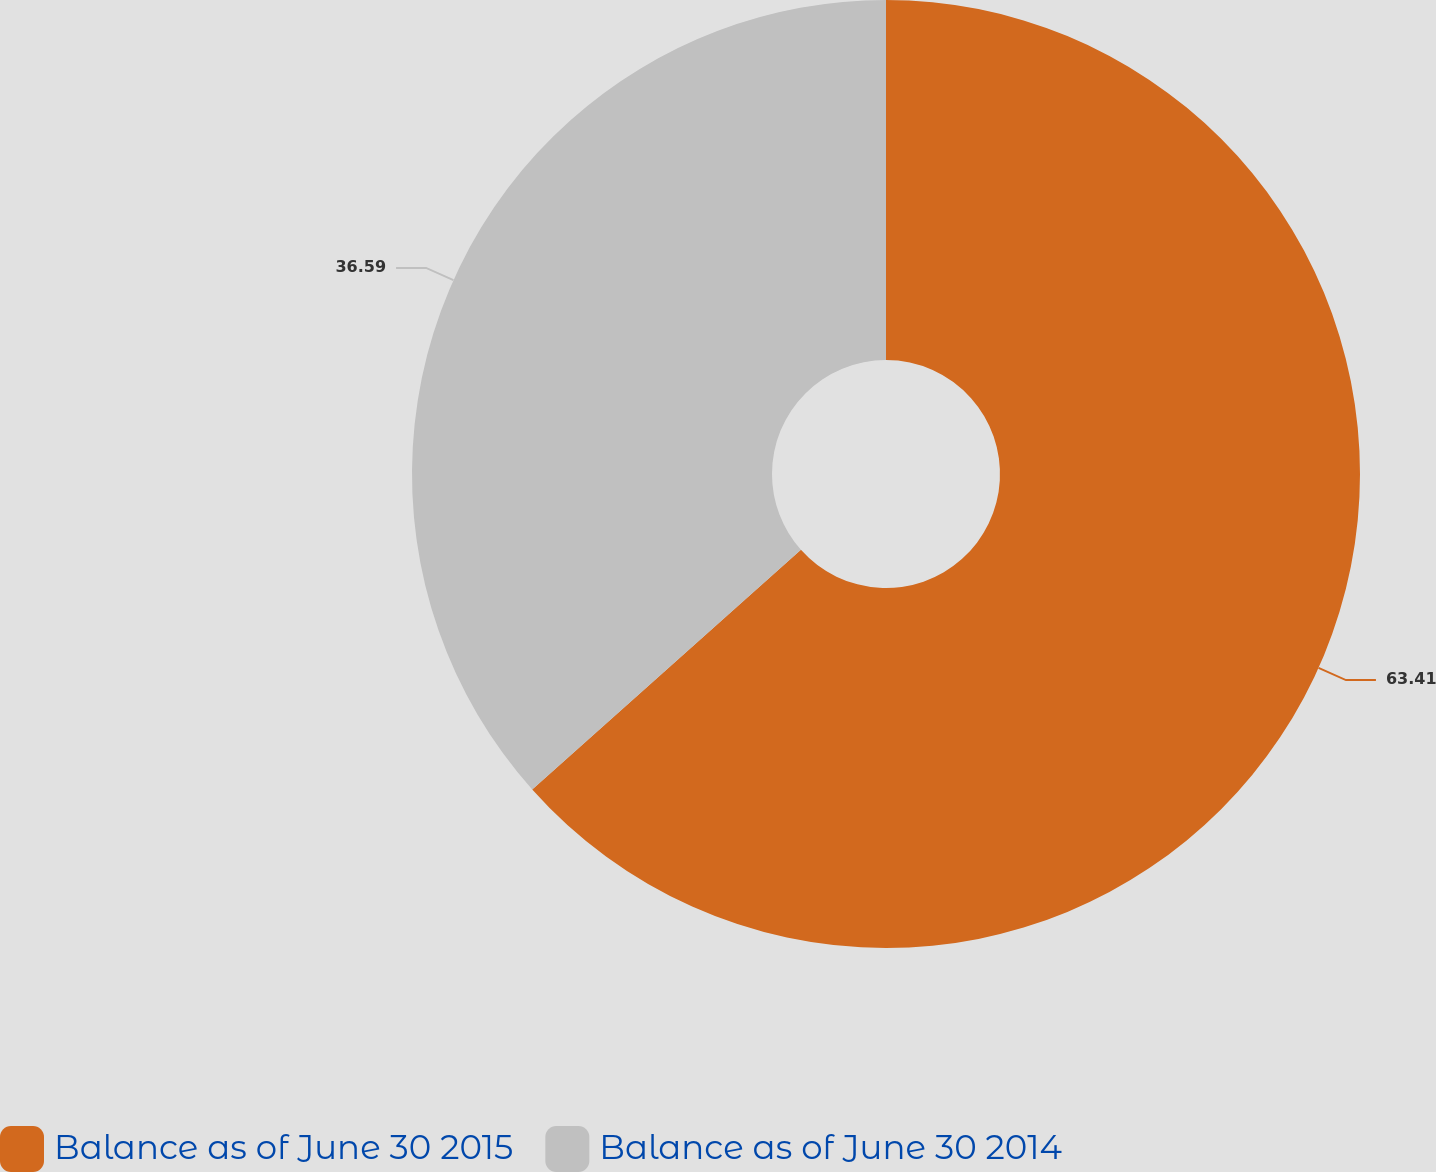Convert chart to OTSL. <chart><loc_0><loc_0><loc_500><loc_500><pie_chart><fcel>Balance as of June 30 2015<fcel>Balance as of June 30 2014<nl><fcel>63.41%<fcel>36.59%<nl></chart> 